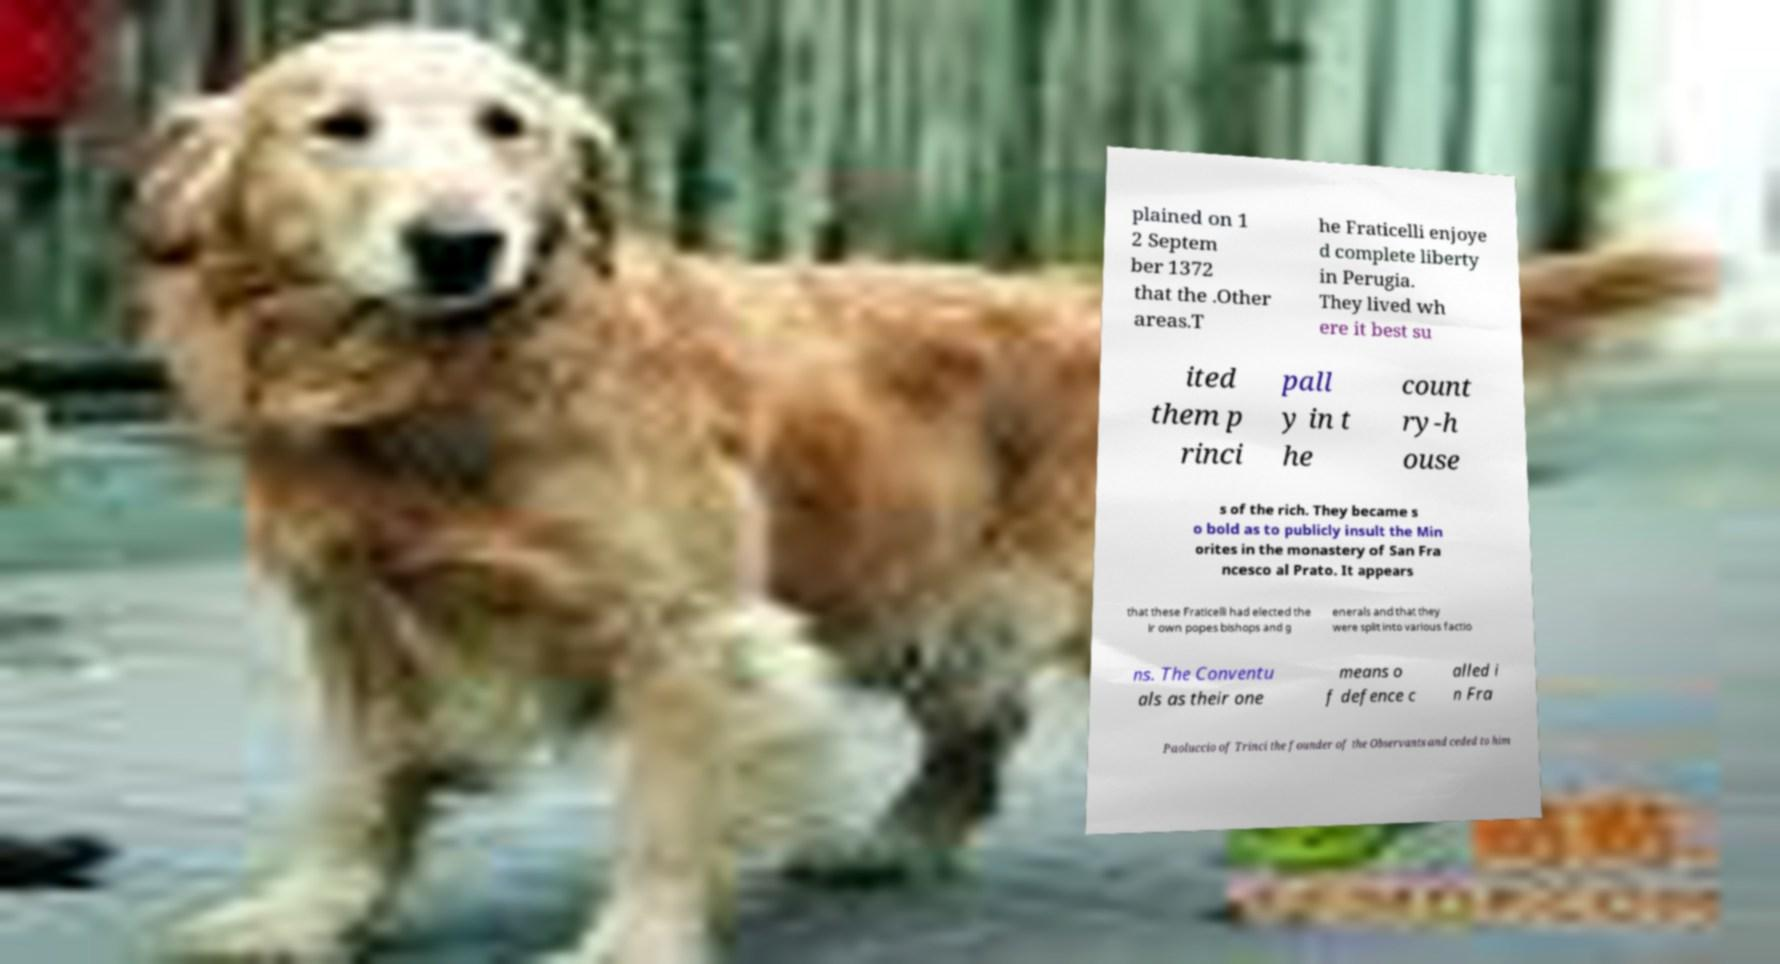Please read and relay the text visible in this image. What does it say? plained on 1 2 Septem ber 1372 that the .Other areas.T he Fraticelli enjoye d complete liberty in Perugia. They lived wh ere it best su ited them p rinci pall y in t he count ry-h ouse s of the rich. They became s o bold as to publicly insult the Min orites in the monastery of San Fra ncesco al Prato. It appears that these Fraticelli had elected the ir own popes bishops and g enerals and that they were split into various factio ns. The Conventu als as their one means o f defence c alled i n Fra Paoluccio of Trinci the founder of the Observants and ceded to him 